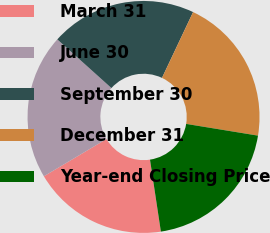Convert chart to OTSL. <chart><loc_0><loc_0><loc_500><loc_500><pie_chart><fcel>March 31<fcel>June 30<fcel>September 30<fcel>December 31<fcel>Year-end Closing Price<nl><fcel>18.84%<fcel>20.2%<fcel>20.37%<fcel>20.55%<fcel>20.03%<nl></chart> 